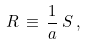<formula> <loc_0><loc_0><loc_500><loc_500>R \, \equiv \, \frac { 1 } { a } \, S \, ,</formula> 